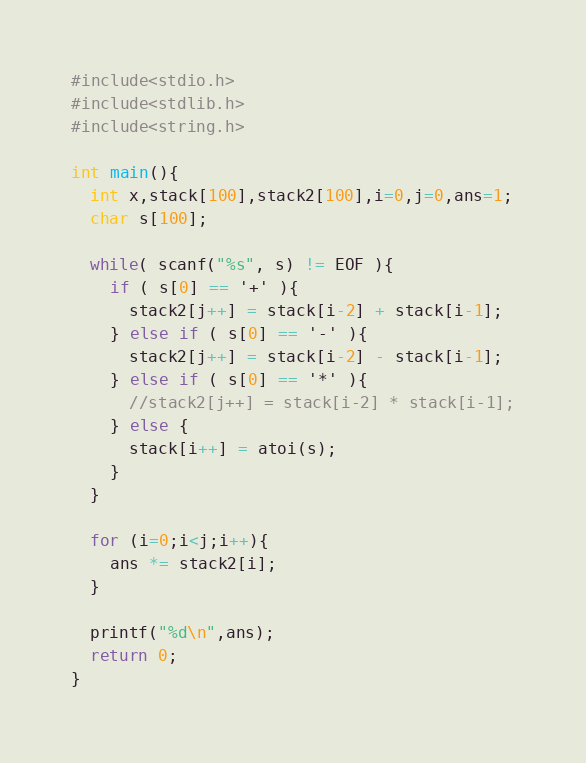<code> <loc_0><loc_0><loc_500><loc_500><_C_>#include<stdio.h>
#include<stdlib.h>
#include<string.h>

int main(){
  int x,stack[100],stack2[100],i=0,j=0,ans=1;
  char s[100];

  while( scanf("%s", s) != EOF ){
    if ( s[0] == '+' ){
      stack2[j++] = stack[i-2] + stack[i-1];
    } else if ( s[0] == '-' ){
      stack2[j++] = stack[i-2] - stack[i-1];
    } else if ( s[0] == '*' ){
      //stack2[j++] = stack[i-2] * stack[i-1];
    } else {
      stack[i++] = atoi(s);
    }
  }

  for (i=0;i<j;i++){
    ans *= stack2[i];
  }

  printf("%d\n",ans);
  return 0;
}</code> 